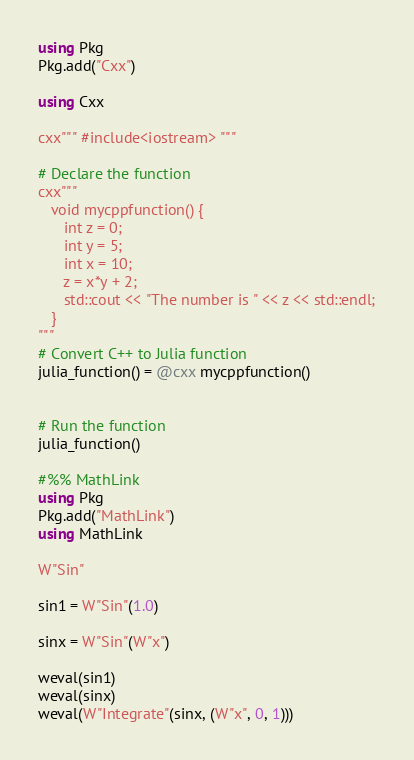Convert code to text. <code><loc_0><loc_0><loc_500><loc_500><_Julia_>using Pkg
Pkg.add("Cxx")

using Cxx

cxx""" #include<iostream> """

# Declare the function
cxx"""
   void mycppfunction() {
      int z = 0;
      int y = 5;
      int x = 10;
      z = x*y + 2;
      std::cout << "The number is " << z << std::endl;
   }
"""
# Convert C++ to Julia function
julia_function() = @cxx mycppfunction()


# Run the function
julia_function()

#%% MathLink
using Pkg
Pkg.add("MathLink")
using MathLink

W"Sin"

sin1 = W"Sin"(1.0)

sinx = W"Sin"(W"x")

weval(sin1)
weval(sinx)
weval(W"Integrate"(sinx, (W"x", 0, 1)))
</code> 